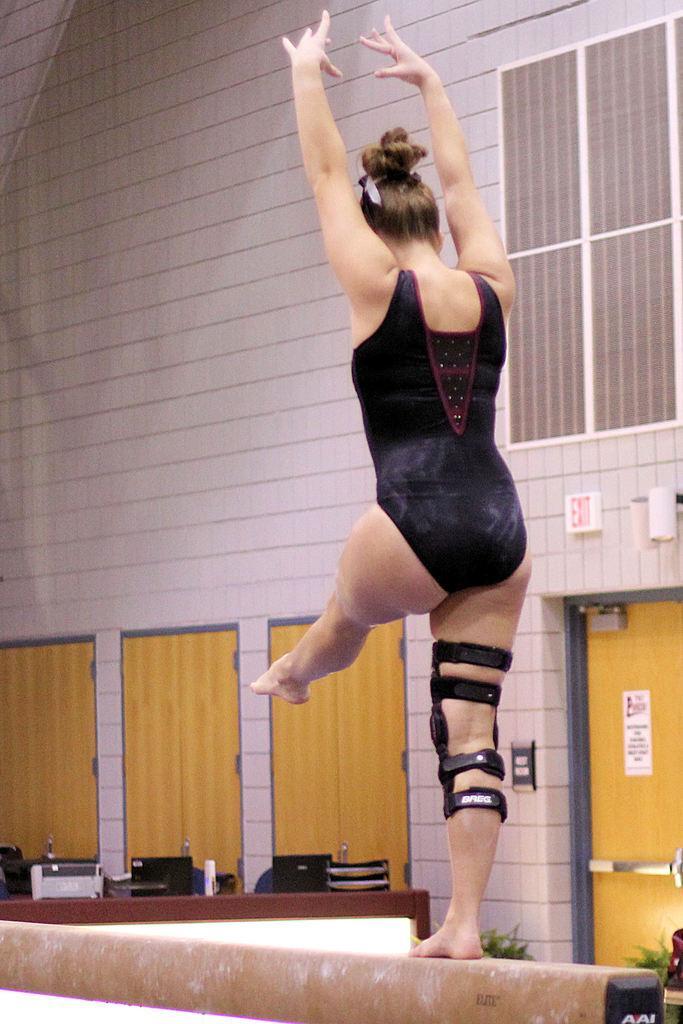Could you give a brief overview of what you see in this image? In this picture we can see a woman and in the background we can see a wall, plants and some objects. 